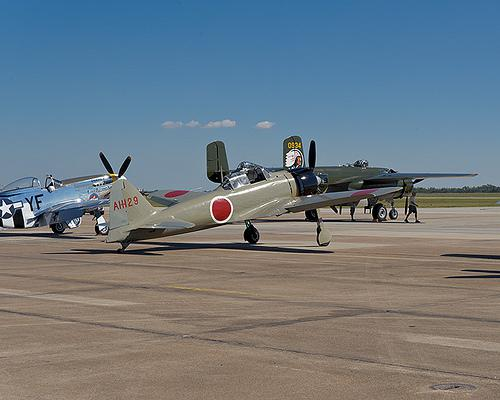Question: why there is a man next to the dark plane?
Choices:
A. He is inspecting it.
B. He is going to ride it.
C. He is washing it.
D. He is repairing it.
Answer with the letter. Answer: A Question: how many planes?
Choices:
A. Three.
B. Two.
C. One.
D. Four.
Answer with the letter. Answer: A 